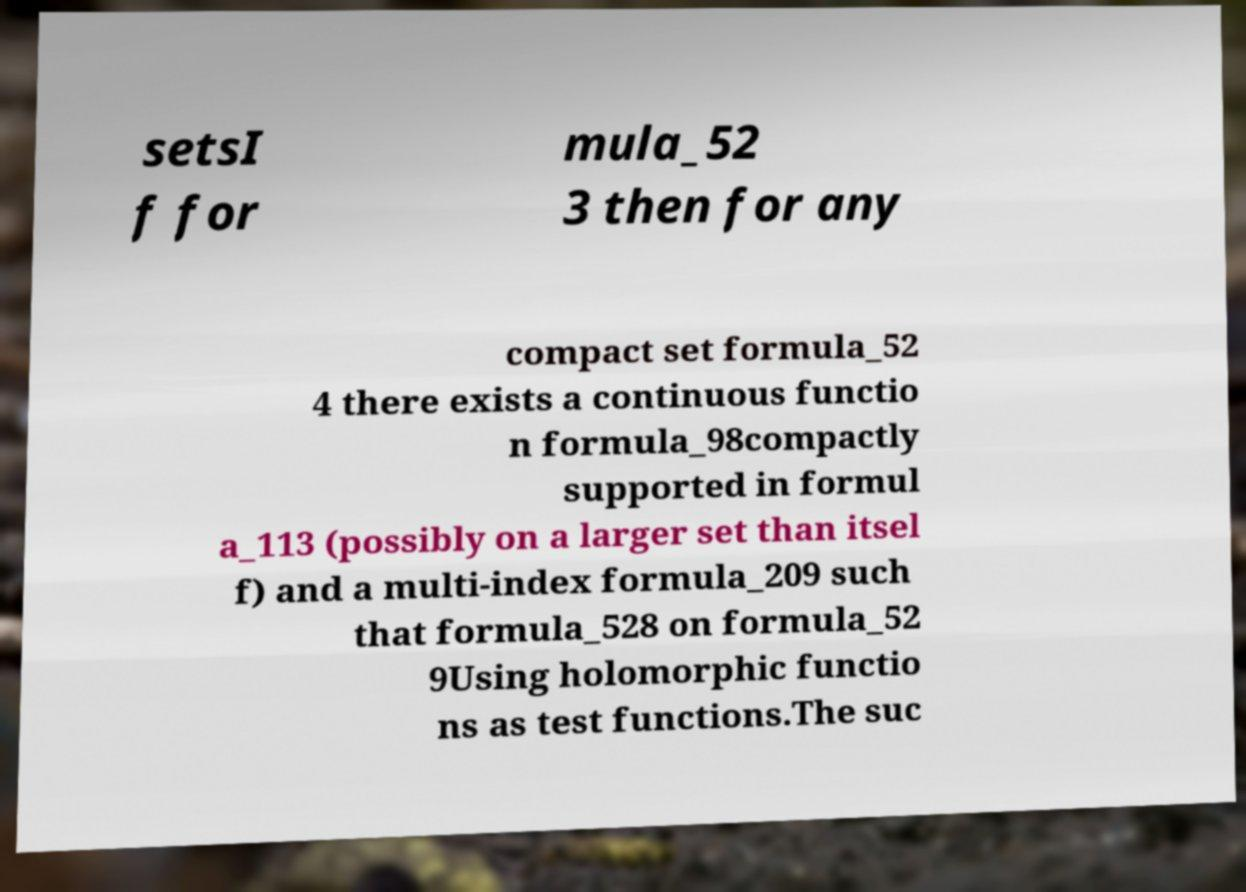There's text embedded in this image that I need extracted. Can you transcribe it verbatim? setsI f for mula_52 3 then for any compact set formula_52 4 there exists a continuous functio n formula_98compactly supported in formul a_113 (possibly on a larger set than itsel f) and a multi-index formula_209 such that formula_528 on formula_52 9Using holomorphic functio ns as test functions.The suc 